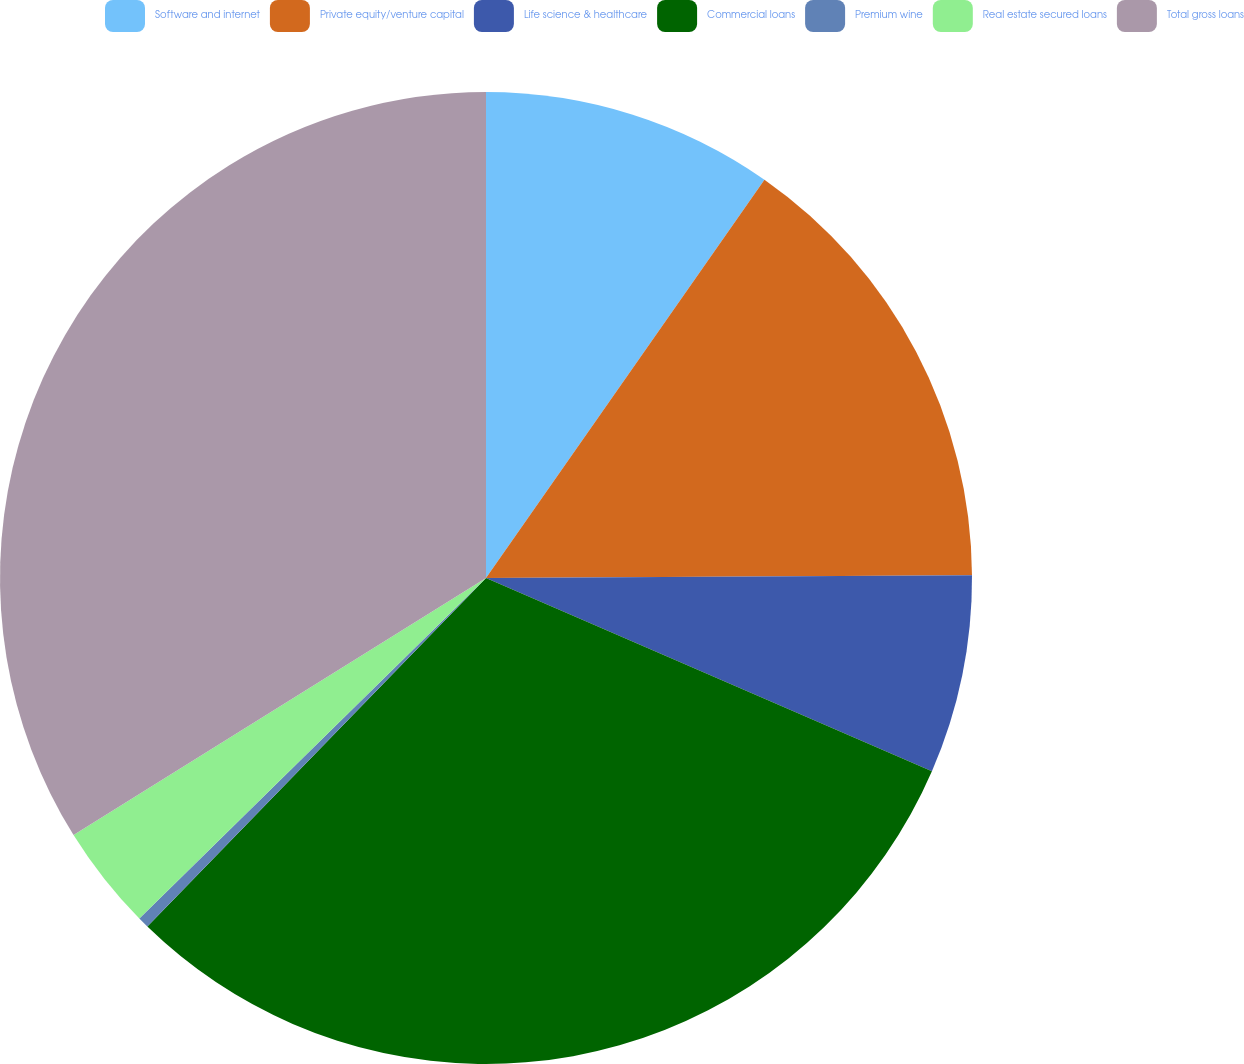Convert chart to OTSL. <chart><loc_0><loc_0><loc_500><loc_500><pie_chart><fcel>Software and internet<fcel>Private equity/venture capital<fcel>Life science & healthcare<fcel>Commercial loans<fcel>Premium wine<fcel>Real estate secured loans<fcel>Total gross loans<nl><fcel>9.71%<fcel>15.2%<fcel>6.6%<fcel>30.76%<fcel>0.37%<fcel>3.49%<fcel>33.87%<nl></chart> 